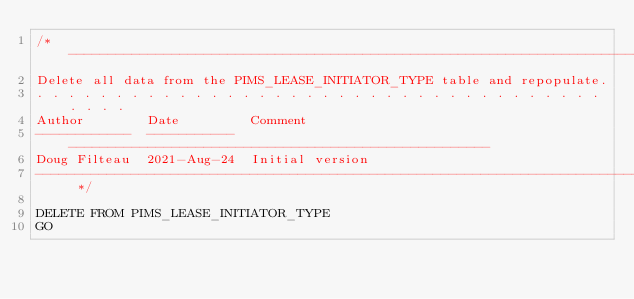<code> <loc_0><loc_0><loc_500><loc_500><_SQL_>/* -----------------------------------------------------------------------------
Delete all data from the PIMS_LEASE_INITIATOR_TYPE table and repopulate.
. . . . . . . . . . . . . . . . . . . . . . . . . . . . . . . . . . . . . . . . 
Author        Date         Comment
------------  -----------  -----------------------------------------------------
Doug Filteau  2021-Aug-24  Initial version
----------------------------------------------------------------------------- */

DELETE FROM PIMS_LEASE_INITIATOR_TYPE
GO</code> 